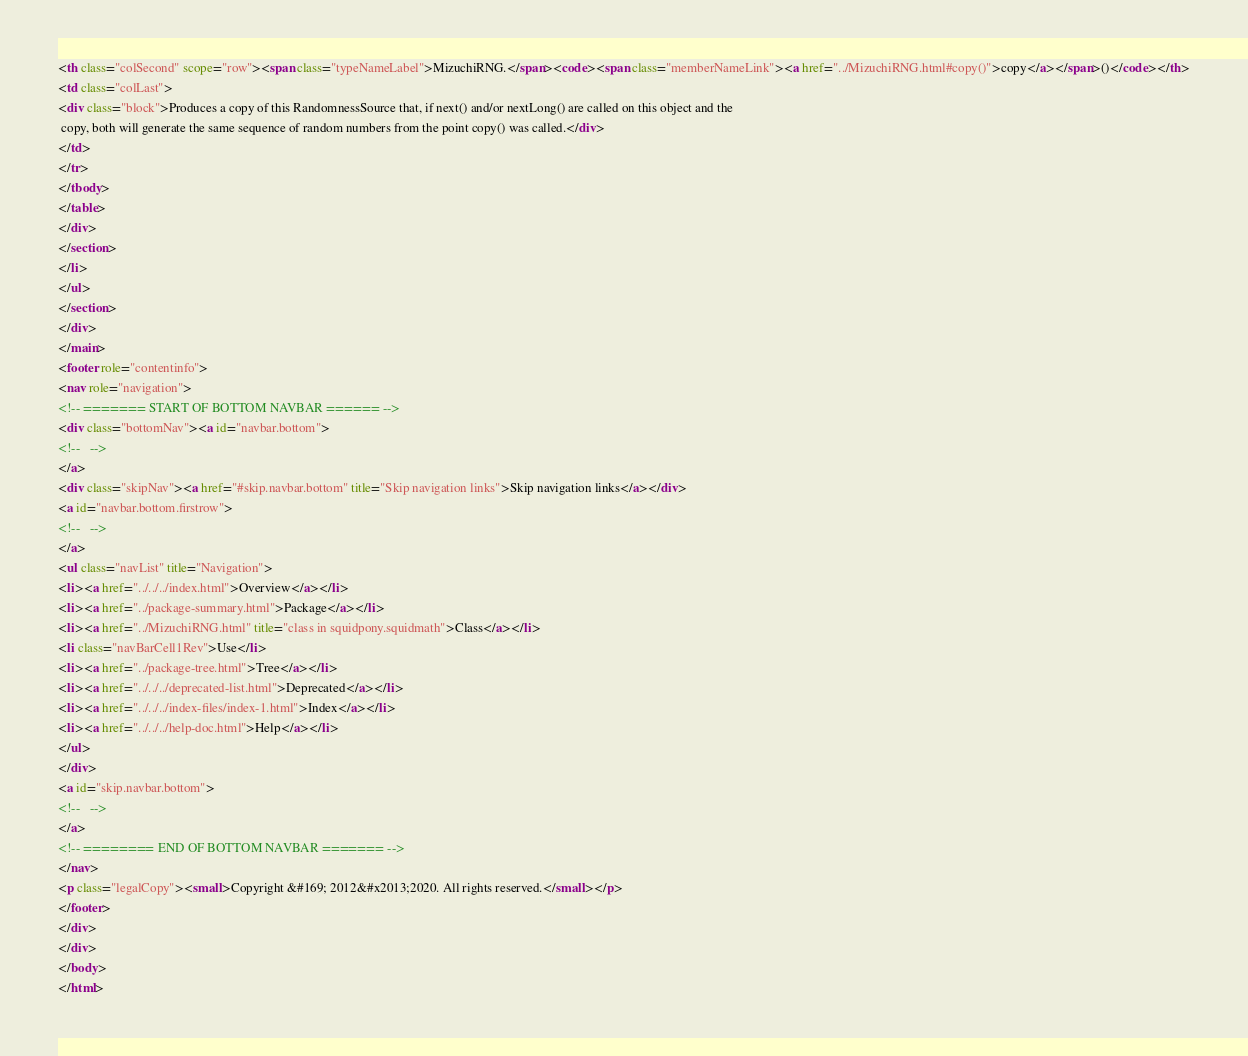<code> <loc_0><loc_0><loc_500><loc_500><_HTML_><th class="colSecond" scope="row"><span class="typeNameLabel">MizuchiRNG.</span><code><span class="memberNameLink"><a href="../MizuchiRNG.html#copy()">copy</a></span>()</code></th>
<td class="colLast">
<div class="block">Produces a copy of this RandomnessSource that, if next() and/or nextLong() are called on this object and the
 copy, both will generate the same sequence of random numbers from the point copy() was called.</div>
</td>
</tr>
</tbody>
</table>
</div>
</section>
</li>
</ul>
</section>
</div>
</main>
<footer role="contentinfo">
<nav role="navigation">
<!-- ======= START OF BOTTOM NAVBAR ====== -->
<div class="bottomNav"><a id="navbar.bottom">
<!--   -->
</a>
<div class="skipNav"><a href="#skip.navbar.bottom" title="Skip navigation links">Skip navigation links</a></div>
<a id="navbar.bottom.firstrow">
<!--   -->
</a>
<ul class="navList" title="Navigation">
<li><a href="../../../index.html">Overview</a></li>
<li><a href="../package-summary.html">Package</a></li>
<li><a href="../MizuchiRNG.html" title="class in squidpony.squidmath">Class</a></li>
<li class="navBarCell1Rev">Use</li>
<li><a href="../package-tree.html">Tree</a></li>
<li><a href="../../../deprecated-list.html">Deprecated</a></li>
<li><a href="../../../index-files/index-1.html">Index</a></li>
<li><a href="../../../help-doc.html">Help</a></li>
</ul>
</div>
<a id="skip.navbar.bottom">
<!--   -->
</a>
<!-- ======== END OF BOTTOM NAVBAR ======= -->
</nav>
<p class="legalCopy"><small>Copyright &#169; 2012&#x2013;2020. All rights reserved.</small></p>
</footer>
</div>
</div>
</body>
</html>
</code> 